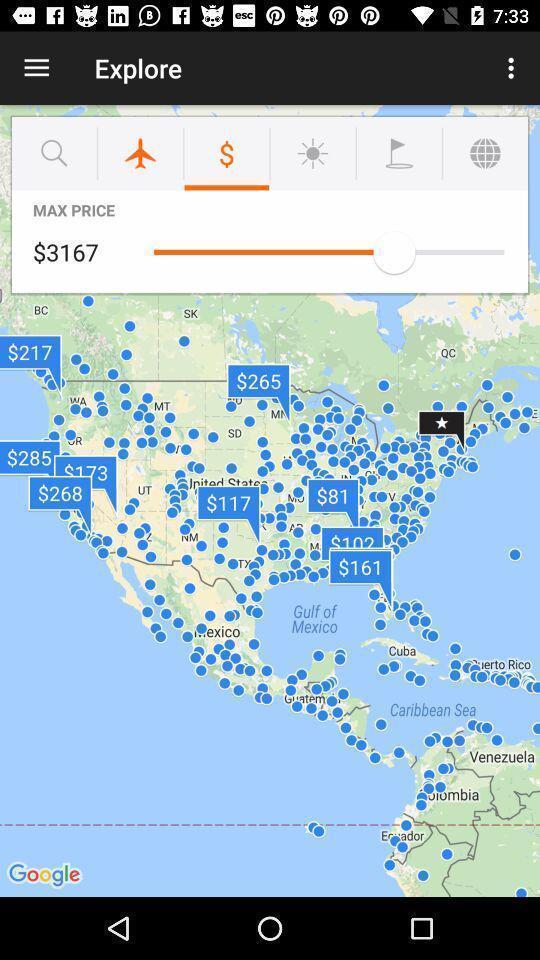Describe the key features of this screenshot. Screen displaying the explore page. 